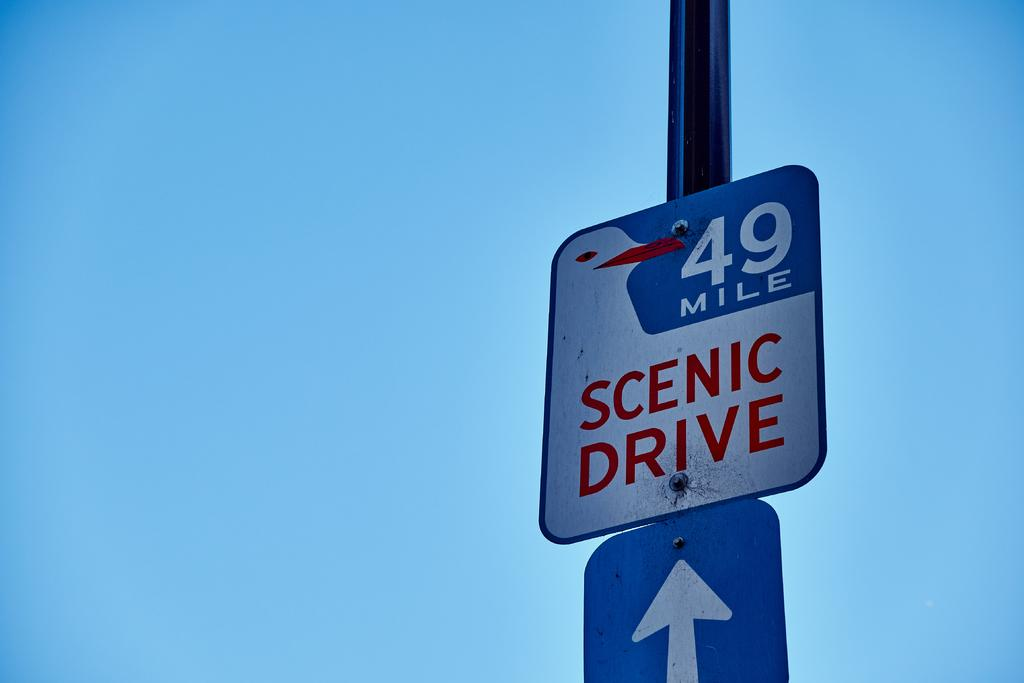<image>
Create a compact narrative representing the image presented. A sign that says 49 Mile scenic drive. 